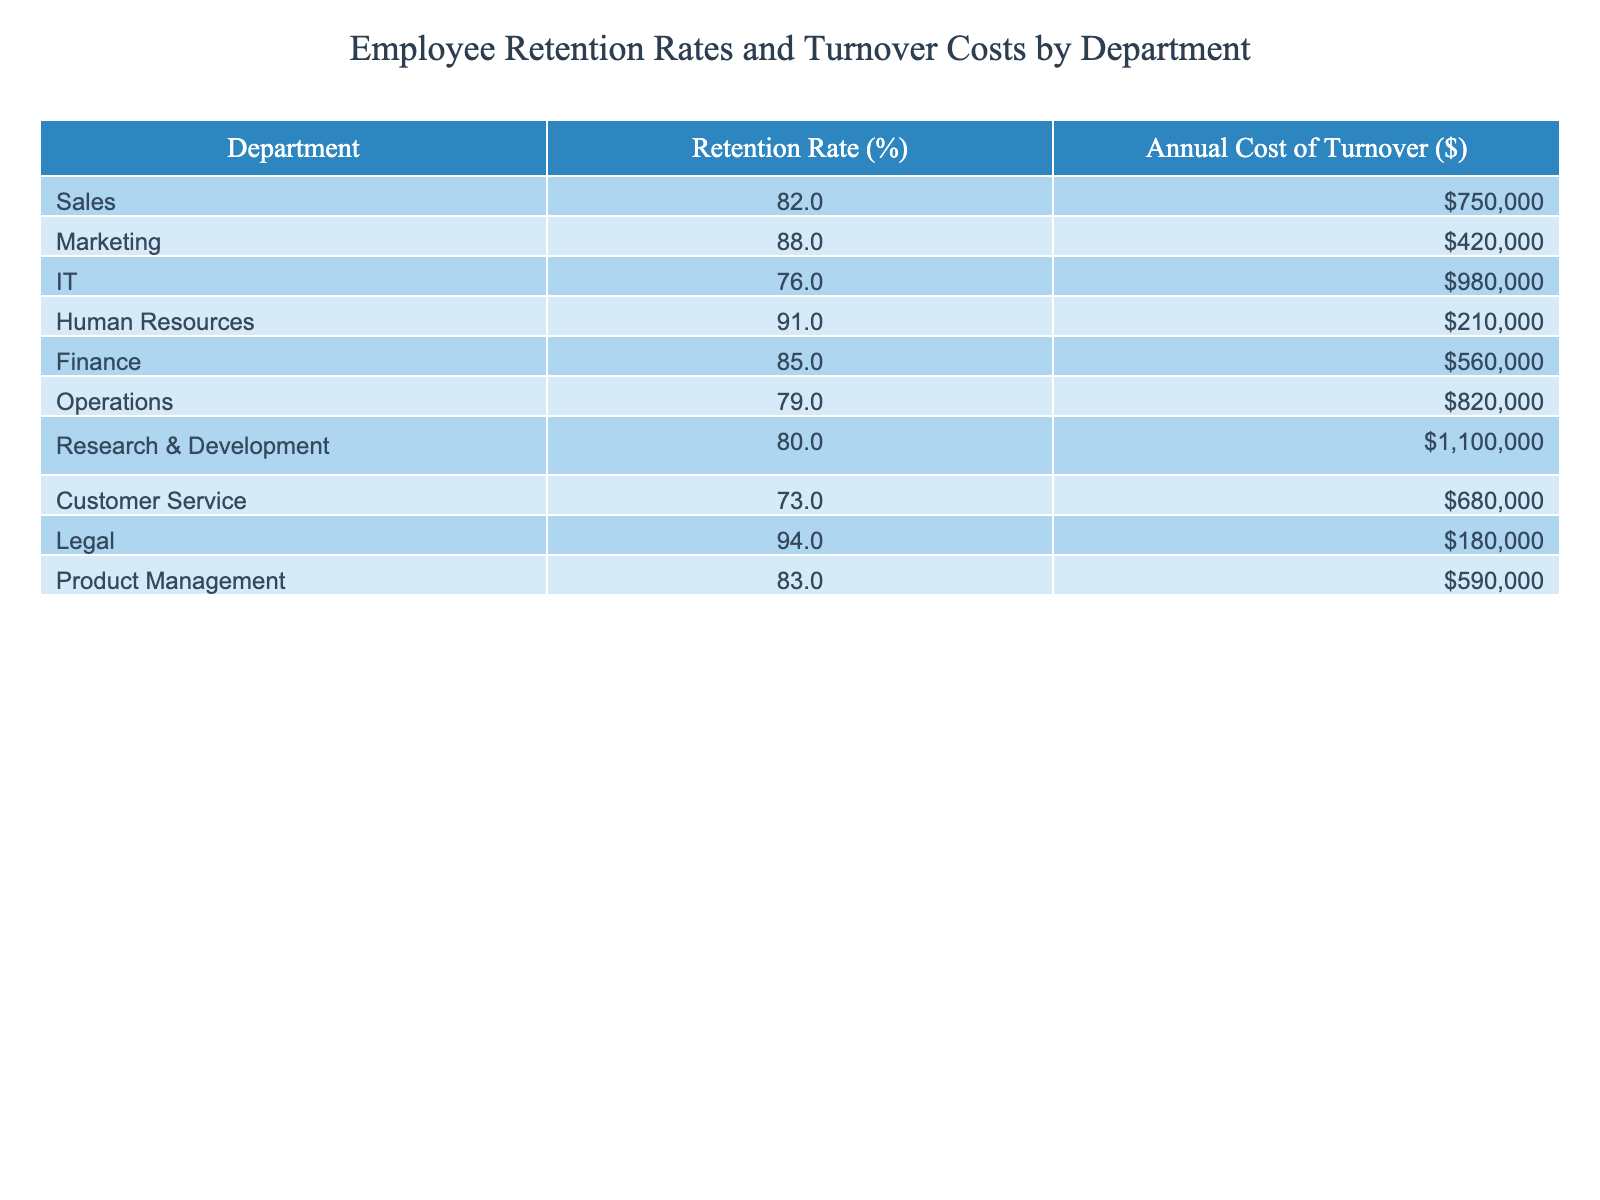What is the retention rate for the Human Resources department? The table shows that the retention rate for Human Resources is 91%.
Answer: 91% Which department has the highest annual cost of turnover? By comparing the annual costs listed in the table, Research & Development has the highest cost at $1,100,000.
Answer: $1,100,000 What is the average retention rate across all departments? To find the average, sum all the retention rates (82 + 88 + 76 + 91 + 85 + 79 + 80 + 73 + 94 + 83 =  829) and divide by the number of departments (10), which results in 82.9%.
Answer: 82.9% Is the retention rate for the IT department higher than that for Customer Service? The retention rate for IT is 76% and for Customer Service is 73%. Since 76% is greater than 73%, the statement is true.
Answer: Yes Which department has a retention rate lower than 80% and what is its turnover cost? Customer Service has a retention rate of 73%, which is below 80%, and its annual turnover cost is $680,000.
Answer: Customer Service, $680,000 What is the difference in retention rates between the Marketing and Operations departments? The retention rate for Marketing is 88% and for Operations is 79%. The difference is 88% - 79% = 9%.
Answer: 9% How many departments have a retention rate above 85%? In the table, the departments with retention rates above 85% are Marketing (88%), Human Resources (91%), and Legal (94%), totaling three departments.
Answer: 3 What is the total annual cost of turnover for all departments with a retention rate below 80%? The departments with a retention rate below 80% are IT (cost $980,000), Operations (cost $820,000), and Customer Service (cost $680,000). The total cost is 980,000 + 820,000 + 680,000 = $2,480,000.
Answer: $2,480,000 Do all departments with a retention rate over 90% have lower turnover costs than the department with the highest turnover cost? The departments with retention rates over 90% are Human Resources (cost $210,000) and Legal (cost $180,000). The highest turnover cost is $1,100,000 (Research & Development). Since both turnover costs are lower than $1,100,000, the statement is true.
Answer: Yes Which department has the lowest retention rate, and how much does it cost to replace employees in that department? The department with the lowest retention rate is Customer Service at 73%, and the associated turnover cost is $680,000.
Answer: Customer Service, $680,000 